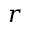<formula> <loc_0><loc_0><loc_500><loc_500>r</formula> 